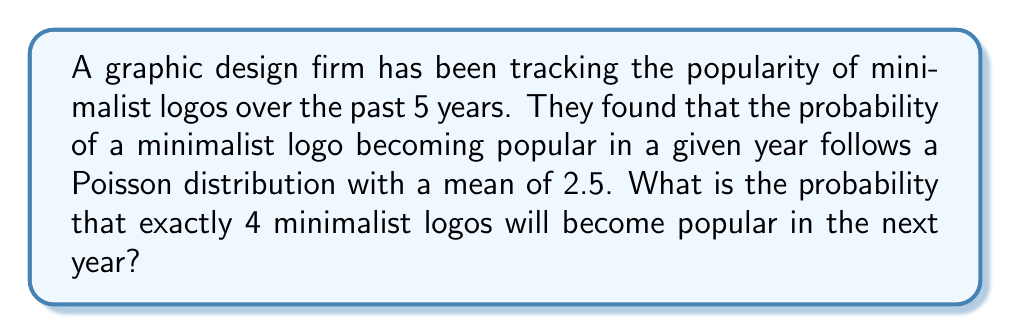Give your solution to this math problem. To solve this problem, we'll use the Poisson probability mass function:

$$P(X = k) = \frac{e^{-\lambda} \lambda^k}{k!}$$

Where:
$\lambda$ = mean number of events (2.5 in this case)
$k$ = number of events we're interested in (4 in this case)
$e$ = Euler's number (approximately 2.71828)

Let's solve step by step:

1) Substitute the values into the formula:
   $$P(X = 4) = \frac{e^{-2.5} 2.5^4}{4!}$$

2) Calculate $e^{-2.5}$:
   $e^{-2.5} \approx 0.0820$

3) Calculate $2.5^4$:
   $2.5^4 = 39.0625$

4) Calculate $4!$:
   $4! = 4 \times 3 \times 2 \times 1 = 24$

5) Put it all together:
   $$P(X = 4) = \frac{0.0820 \times 39.0625}{24} \approx 0.1336$$

6) Convert to a percentage:
   $0.1336 \times 100\% = 13.36\%$

Therefore, the probability of exactly 4 minimalist logos becoming popular in the next year is approximately 13.36%.
Answer: 13.36% 